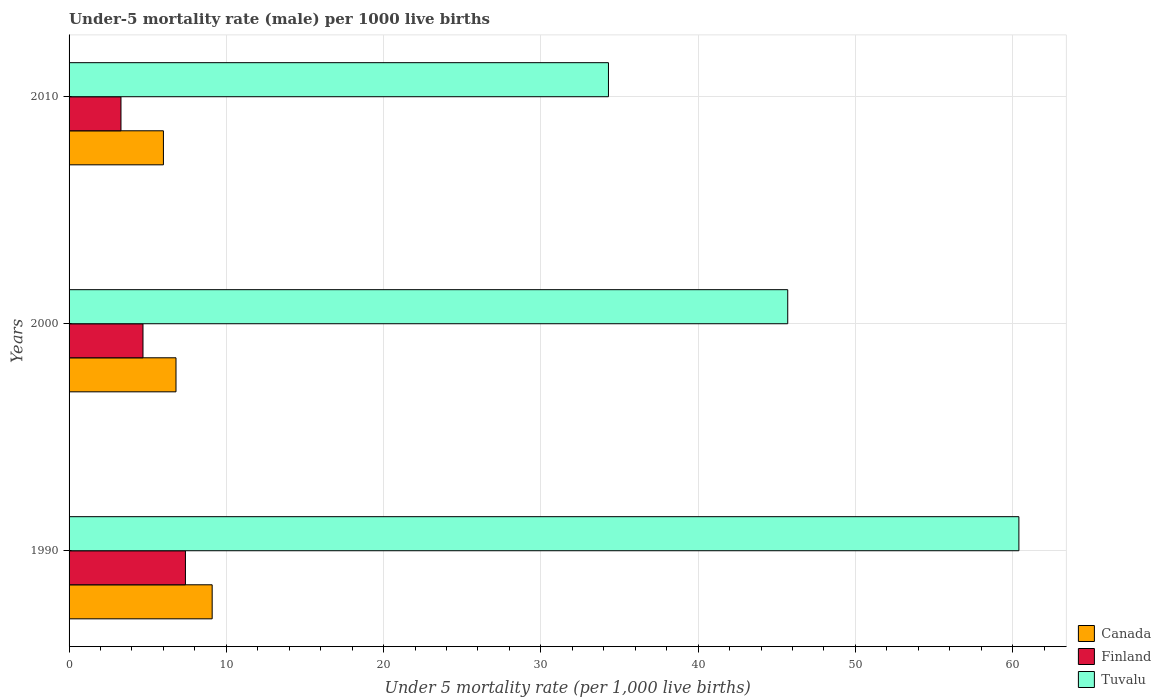How many groups of bars are there?
Ensure brevity in your answer.  3. Are the number of bars per tick equal to the number of legend labels?
Ensure brevity in your answer.  Yes. Are the number of bars on each tick of the Y-axis equal?
Offer a very short reply. Yes. How many bars are there on the 3rd tick from the bottom?
Make the answer very short. 3. What is the label of the 3rd group of bars from the top?
Your response must be concise. 1990. In how many cases, is the number of bars for a given year not equal to the number of legend labels?
Offer a terse response. 0. What is the under-five mortality rate in Finland in 1990?
Offer a terse response. 7.4. Across all years, what is the maximum under-five mortality rate in Tuvalu?
Your answer should be compact. 60.4. Across all years, what is the minimum under-five mortality rate in Canada?
Your answer should be compact. 6. In which year was the under-five mortality rate in Finland minimum?
Provide a succinct answer. 2010. What is the total under-five mortality rate in Tuvalu in the graph?
Keep it short and to the point. 140.4. What is the difference between the under-five mortality rate in Tuvalu in 2000 and that in 2010?
Give a very brief answer. 11.4. What is the difference between the under-five mortality rate in Canada in 1990 and the under-five mortality rate in Tuvalu in 2010?
Provide a short and direct response. -25.2. What is the average under-five mortality rate in Finland per year?
Offer a terse response. 5.13. In the year 2000, what is the difference between the under-five mortality rate in Finland and under-five mortality rate in Canada?
Give a very brief answer. -2.1. What is the ratio of the under-five mortality rate in Tuvalu in 1990 to that in 2010?
Your answer should be compact. 1.76. What is the difference between the highest and the second highest under-five mortality rate in Canada?
Keep it short and to the point. 2.3. What is the difference between the highest and the lowest under-five mortality rate in Canada?
Provide a short and direct response. 3.1. In how many years, is the under-five mortality rate in Tuvalu greater than the average under-five mortality rate in Tuvalu taken over all years?
Ensure brevity in your answer.  1. What does the 3rd bar from the top in 1990 represents?
Give a very brief answer. Canada. How many bars are there?
Your answer should be compact. 9. Are all the bars in the graph horizontal?
Offer a very short reply. Yes. What is the difference between two consecutive major ticks on the X-axis?
Your response must be concise. 10. Does the graph contain any zero values?
Provide a short and direct response. No. Does the graph contain grids?
Offer a terse response. Yes. Where does the legend appear in the graph?
Your answer should be compact. Bottom right. How many legend labels are there?
Offer a terse response. 3. How are the legend labels stacked?
Provide a succinct answer. Vertical. What is the title of the graph?
Offer a terse response. Under-5 mortality rate (male) per 1000 live births. Does "Brazil" appear as one of the legend labels in the graph?
Provide a succinct answer. No. What is the label or title of the X-axis?
Keep it short and to the point. Under 5 mortality rate (per 1,0 live births). What is the Under 5 mortality rate (per 1,000 live births) of Canada in 1990?
Provide a succinct answer. 9.1. What is the Under 5 mortality rate (per 1,000 live births) of Tuvalu in 1990?
Provide a succinct answer. 60.4. What is the Under 5 mortality rate (per 1,000 live births) of Canada in 2000?
Your answer should be very brief. 6.8. What is the Under 5 mortality rate (per 1,000 live births) of Tuvalu in 2000?
Your response must be concise. 45.7. What is the Under 5 mortality rate (per 1,000 live births) of Tuvalu in 2010?
Make the answer very short. 34.3. Across all years, what is the maximum Under 5 mortality rate (per 1,000 live births) in Canada?
Provide a succinct answer. 9.1. Across all years, what is the maximum Under 5 mortality rate (per 1,000 live births) of Finland?
Provide a short and direct response. 7.4. Across all years, what is the maximum Under 5 mortality rate (per 1,000 live births) of Tuvalu?
Offer a terse response. 60.4. Across all years, what is the minimum Under 5 mortality rate (per 1,000 live births) of Canada?
Offer a very short reply. 6. Across all years, what is the minimum Under 5 mortality rate (per 1,000 live births) of Finland?
Ensure brevity in your answer.  3.3. Across all years, what is the minimum Under 5 mortality rate (per 1,000 live births) in Tuvalu?
Provide a succinct answer. 34.3. What is the total Under 5 mortality rate (per 1,000 live births) of Canada in the graph?
Your response must be concise. 21.9. What is the total Under 5 mortality rate (per 1,000 live births) of Tuvalu in the graph?
Ensure brevity in your answer.  140.4. What is the difference between the Under 5 mortality rate (per 1,000 live births) of Finland in 1990 and that in 2000?
Provide a short and direct response. 2.7. What is the difference between the Under 5 mortality rate (per 1,000 live births) of Finland in 1990 and that in 2010?
Your answer should be very brief. 4.1. What is the difference between the Under 5 mortality rate (per 1,000 live births) of Tuvalu in 1990 and that in 2010?
Offer a very short reply. 26.1. What is the difference between the Under 5 mortality rate (per 1,000 live births) of Canada in 2000 and that in 2010?
Provide a short and direct response. 0.8. What is the difference between the Under 5 mortality rate (per 1,000 live births) in Finland in 2000 and that in 2010?
Make the answer very short. 1.4. What is the difference between the Under 5 mortality rate (per 1,000 live births) in Tuvalu in 2000 and that in 2010?
Ensure brevity in your answer.  11.4. What is the difference between the Under 5 mortality rate (per 1,000 live births) in Canada in 1990 and the Under 5 mortality rate (per 1,000 live births) in Finland in 2000?
Keep it short and to the point. 4.4. What is the difference between the Under 5 mortality rate (per 1,000 live births) in Canada in 1990 and the Under 5 mortality rate (per 1,000 live births) in Tuvalu in 2000?
Give a very brief answer. -36.6. What is the difference between the Under 5 mortality rate (per 1,000 live births) of Finland in 1990 and the Under 5 mortality rate (per 1,000 live births) of Tuvalu in 2000?
Your answer should be compact. -38.3. What is the difference between the Under 5 mortality rate (per 1,000 live births) of Canada in 1990 and the Under 5 mortality rate (per 1,000 live births) of Tuvalu in 2010?
Provide a succinct answer. -25.2. What is the difference between the Under 5 mortality rate (per 1,000 live births) in Finland in 1990 and the Under 5 mortality rate (per 1,000 live births) in Tuvalu in 2010?
Give a very brief answer. -26.9. What is the difference between the Under 5 mortality rate (per 1,000 live births) in Canada in 2000 and the Under 5 mortality rate (per 1,000 live births) in Tuvalu in 2010?
Provide a succinct answer. -27.5. What is the difference between the Under 5 mortality rate (per 1,000 live births) of Finland in 2000 and the Under 5 mortality rate (per 1,000 live births) of Tuvalu in 2010?
Offer a terse response. -29.6. What is the average Under 5 mortality rate (per 1,000 live births) of Finland per year?
Offer a terse response. 5.13. What is the average Under 5 mortality rate (per 1,000 live births) in Tuvalu per year?
Offer a very short reply. 46.8. In the year 1990, what is the difference between the Under 5 mortality rate (per 1,000 live births) in Canada and Under 5 mortality rate (per 1,000 live births) in Tuvalu?
Ensure brevity in your answer.  -51.3. In the year 1990, what is the difference between the Under 5 mortality rate (per 1,000 live births) of Finland and Under 5 mortality rate (per 1,000 live births) of Tuvalu?
Your response must be concise. -53. In the year 2000, what is the difference between the Under 5 mortality rate (per 1,000 live births) in Canada and Under 5 mortality rate (per 1,000 live births) in Finland?
Offer a very short reply. 2.1. In the year 2000, what is the difference between the Under 5 mortality rate (per 1,000 live births) of Canada and Under 5 mortality rate (per 1,000 live births) of Tuvalu?
Your answer should be compact. -38.9. In the year 2000, what is the difference between the Under 5 mortality rate (per 1,000 live births) in Finland and Under 5 mortality rate (per 1,000 live births) in Tuvalu?
Offer a very short reply. -41. In the year 2010, what is the difference between the Under 5 mortality rate (per 1,000 live births) of Canada and Under 5 mortality rate (per 1,000 live births) of Tuvalu?
Ensure brevity in your answer.  -28.3. In the year 2010, what is the difference between the Under 5 mortality rate (per 1,000 live births) of Finland and Under 5 mortality rate (per 1,000 live births) of Tuvalu?
Keep it short and to the point. -31. What is the ratio of the Under 5 mortality rate (per 1,000 live births) of Canada in 1990 to that in 2000?
Give a very brief answer. 1.34. What is the ratio of the Under 5 mortality rate (per 1,000 live births) of Finland in 1990 to that in 2000?
Provide a short and direct response. 1.57. What is the ratio of the Under 5 mortality rate (per 1,000 live births) in Tuvalu in 1990 to that in 2000?
Make the answer very short. 1.32. What is the ratio of the Under 5 mortality rate (per 1,000 live births) of Canada in 1990 to that in 2010?
Your response must be concise. 1.52. What is the ratio of the Under 5 mortality rate (per 1,000 live births) of Finland in 1990 to that in 2010?
Your answer should be compact. 2.24. What is the ratio of the Under 5 mortality rate (per 1,000 live births) of Tuvalu in 1990 to that in 2010?
Offer a terse response. 1.76. What is the ratio of the Under 5 mortality rate (per 1,000 live births) in Canada in 2000 to that in 2010?
Offer a very short reply. 1.13. What is the ratio of the Under 5 mortality rate (per 1,000 live births) in Finland in 2000 to that in 2010?
Offer a very short reply. 1.42. What is the ratio of the Under 5 mortality rate (per 1,000 live births) in Tuvalu in 2000 to that in 2010?
Provide a succinct answer. 1.33. What is the difference between the highest and the second highest Under 5 mortality rate (per 1,000 live births) of Canada?
Your response must be concise. 2.3. What is the difference between the highest and the second highest Under 5 mortality rate (per 1,000 live births) in Tuvalu?
Offer a terse response. 14.7. What is the difference between the highest and the lowest Under 5 mortality rate (per 1,000 live births) in Canada?
Make the answer very short. 3.1. What is the difference between the highest and the lowest Under 5 mortality rate (per 1,000 live births) in Finland?
Your response must be concise. 4.1. What is the difference between the highest and the lowest Under 5 mortality rate (per 1,000 live births) of Tuvalu?
Provide a succinct answer. 26.1. 